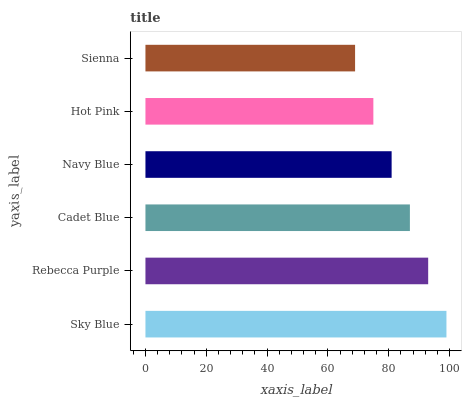Is Sienna the minimum?
Answer yes or no. Yes. Is Sky Blue the maximum?
Answer yes or no. Yes. Is Rebecca Purple the minimum?
Answer yes or no. No. Is Rebecca Purple the maximum?
Answer yes or no. No. Is Sky Blue greater than Rebecca Purple?
Answer yes or no. Yes. Is Rebecca Purple less than Sky Blue?
Answer yes or no. Yes. Is Rebecca Purple greater than Sky Blue?
Answer yes or no. No. Is Sky Blue less than Rebecca Purple?
Answer yes or no. No. Is Cadet Blue the high median?
Answer yes or no. Yes. Is Navy Blue the low median?
Answer yes or no. Yes. Is Rebecca Purple the high median?
Answer yes or no. No. Is Rebecca Purple the low median?
Answer yes or no. No. 